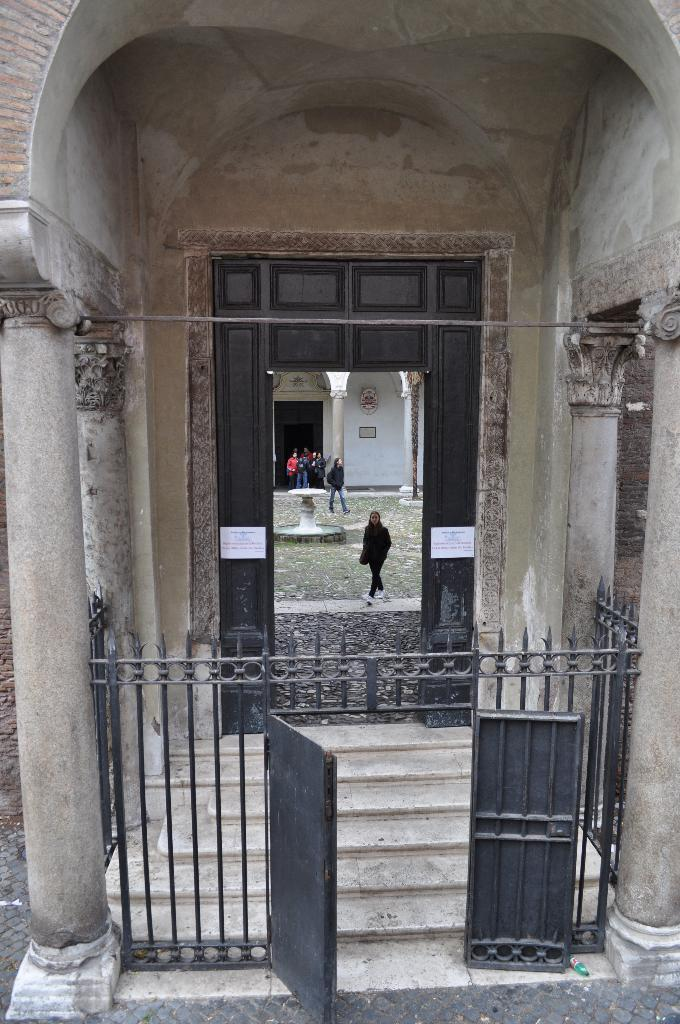What structure can be seen in the image? There is a gate in the image. What architectural elements are present in the image? There are pillars and grilles in the image. What additional objects can be seen in the image? There are posters in the image. What can be observed in the background of the image? In the background of the image, there are people, grass, a water fountain, pillars, and a wall. What color is the basin in the image? There is no basin present in the image. How does the lock on the gate function in the image? There is no lock mentioned or visible in the image. 